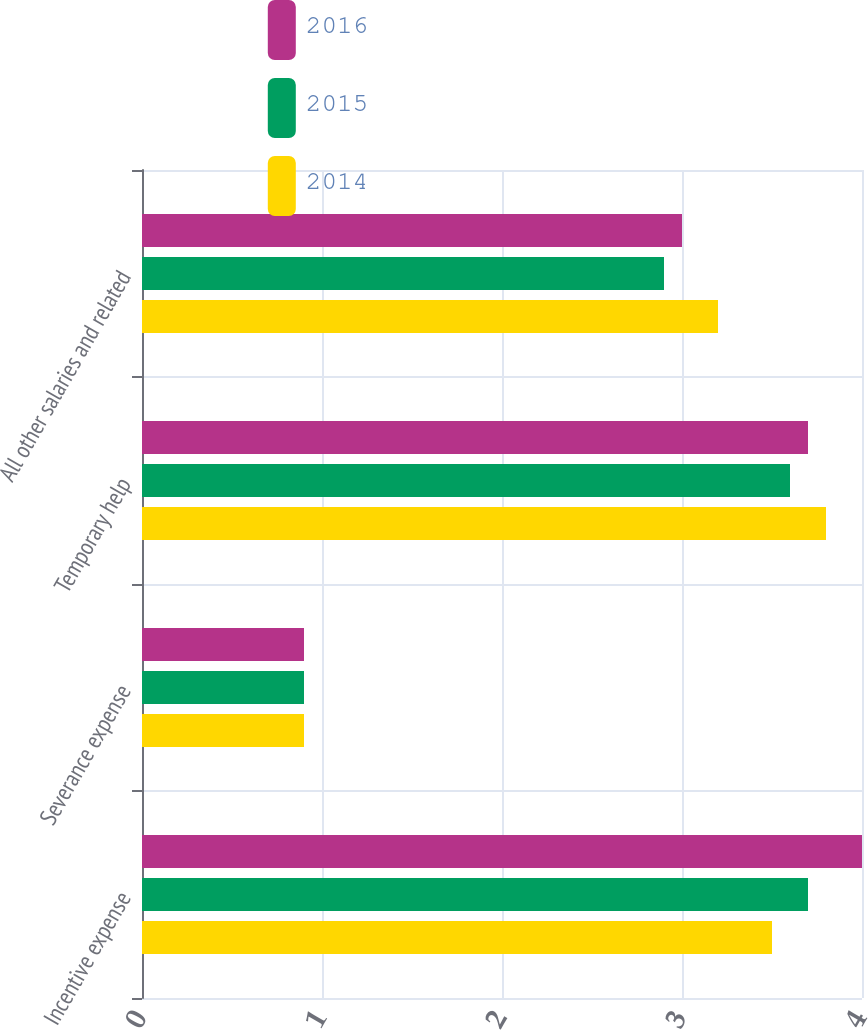<chart> <loc_0><loc_0><loc_500><loc_500><stacked_bar_chart><ecel><fcel>Incentive expense<fcel>Severance expense<fcel>Temporary help<fcel>All other salaries and related<nl><fcel>2016<fcel>4<fcel>0.9<fcel>3.7<fcel>3<nl><fcel>2015<fcel>3.7<fcel>0.9<fcel>3.6<fcel>2.9<nl><fcel>2014<fcel>3.5<fcel>0.9<fcel>3.8<fcel>3.2<nl></chart> 